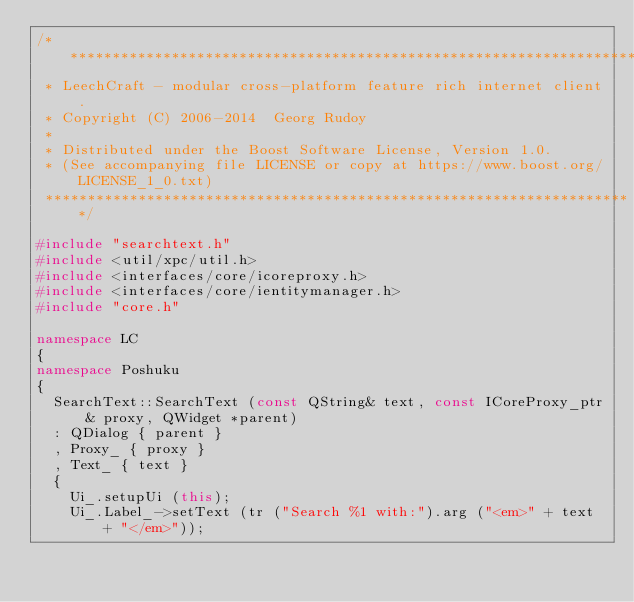<code> <loc_0><loc_0><loc_500><loc_500><_C++_>/**********************************************************************
 * LeechCraft - modular cross-platform feature rich internet client.
 * Copyright (C) 2006-2014  Georg Rudoy
 *
 * Distributed under the Boost Software License, Version 1.0.
 * (See accompanying file LICENSE or copy at https://www.boost.org/LICENSE_1_0.txt)
 **********************************************************************/

#include "searchtext.h"
#include <util/xpc/util.h>
#include <interfaces/core/icoreproxy.h>
#include <interfaces/core/ientitymanager.h>
#include "core.h"

namespace LC
{
namespace Poshuku
{
	SearchText::SearchText (const QString& text, const ICoreProxy_ptr& proxy, QWidget *parent)
	: QDialog { parent }
	, Proxy_ { proxy }
	, Text_ { text }
	{
		Ui_.setupUi (this);
		Ui_.Label_->setText (tr ("Search %1 with:").arg ("<em>" + text + "</em>"));
</code> 